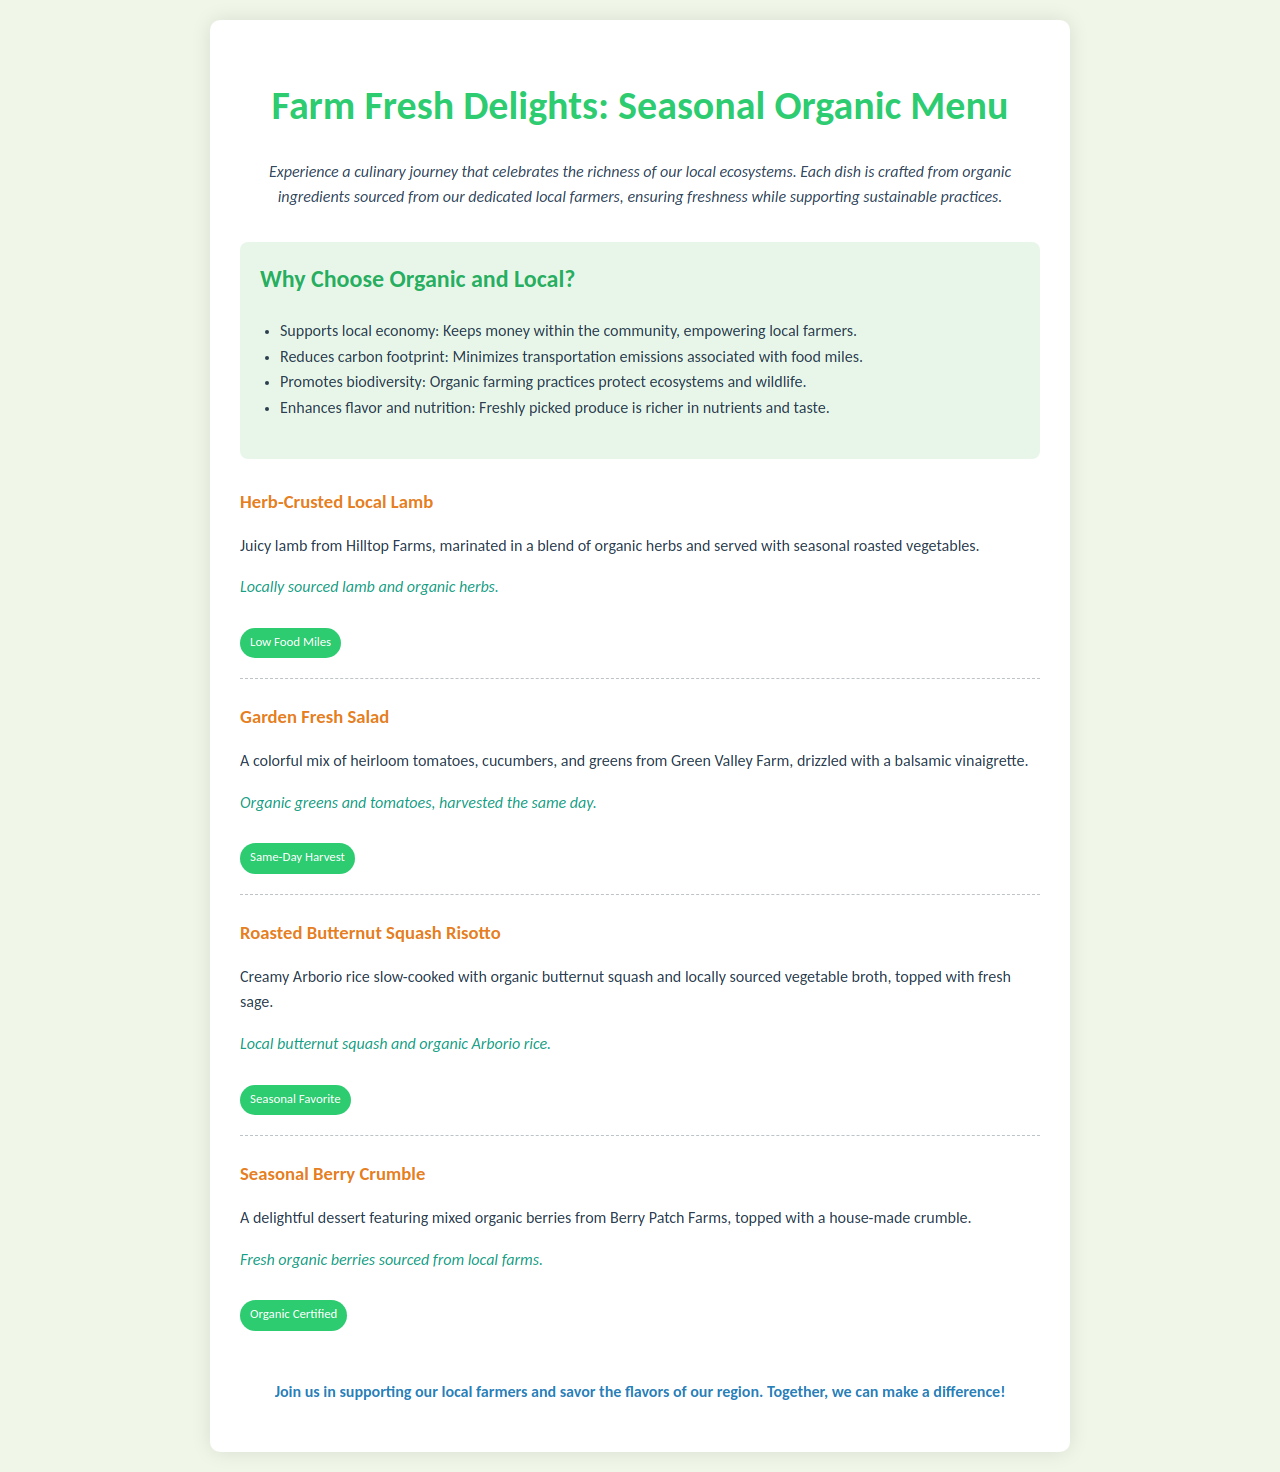What is the title of the menu? The title of the menu is provided at the top of the document as "Farm Fresh Delights: Seasonal Organic Menu."
Answer: Farm Fresh Delights: Seasonal Organic Menu What is one benefit of choosing organic and local produce? The document lists several benefits, one of which is "Supports local economy."
Answer: Supports local economy From which farm is the lamb sourced? The menu specifies that the lamb comes from "Hilltop Farms."
Answer: Hilltop Farms How is the Garden Fresh Salad prepared? The description of the salad indicates that it is "drizzled with a balsamic vinaigrette."
Answer: drizzled with a balsamic vinaigrette What is a key ingredient in the Roasted Butternut Squash Risotto? The description highlights "organic butternut squash" as a key ingredient.
Answer: organic butternut squash Which dessert features organic berries? The menu describes the "Seasonal Berry Crumble" as featuring organic berries.
Answer: Seasonal Berry Crumble How does the menu encourage support for local farmers? The call-to-action at the end asks customers to "Join us in supporting our local farmers."
Answer: Join us in supporting our local farmers What type of rice is used in the risotto? The document states that "Arborio rice" is used in the Roasted Butternut Squash Risotto.
Answer: Arborio rice What label is given to the Garden Fresh Salad? The salad is marked with the label "Same-Day Harvest."
Answer: Same-Day Harvest 